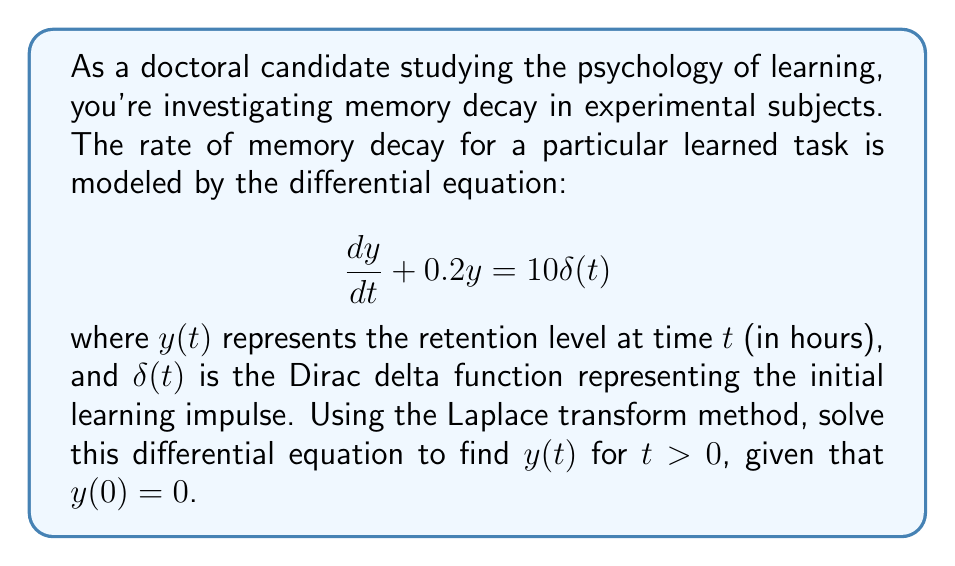Give your solution to this math problem. Let's solve this differential equation using the Laplace transform method:

1) Take the Laplace transform of both sides of the equation:
   $$\mathcal{L}\left\{\frac{dy}{dt} + 0.2y\right\} = \mathcal{L}\{10\delta(t)\}$$

2) Using Laplace transform properties:
   $$sY(s) - y(0) + 0.2Y(s) = 10$$
   where $Y(s)$ is the Laplace transform of $y(t)$, and $y(0) = 0$

3) Simplify:
   $$(s + 0.2)Y(s) = 10$$

4) Solve for $Y(s)$:
   $$Y(s) = \frac{10}{s + 0.2}$$

5) This can be rewritten as:
   $$Y(s) = \frac{10}{0.2}\cdot\frac{1}{s + 0.2} = \frac{50}{s + 0.2}$$

6) The inverse Laplace transform of $\frac{1}{s + a}$ is $e^{-at}$, so:
   $$y(t) = 50e^{-0.2t}$$

This solution represents the memory retention level as a function of time. The initial spike of learning (represented by the delta function) results in an immediate retention level of 50, which then decays exponentially over time with a rate constant of 0.2 per hour.
Answer: $y(t) = 50e^{-0.2t}$ for $t > 0$ 